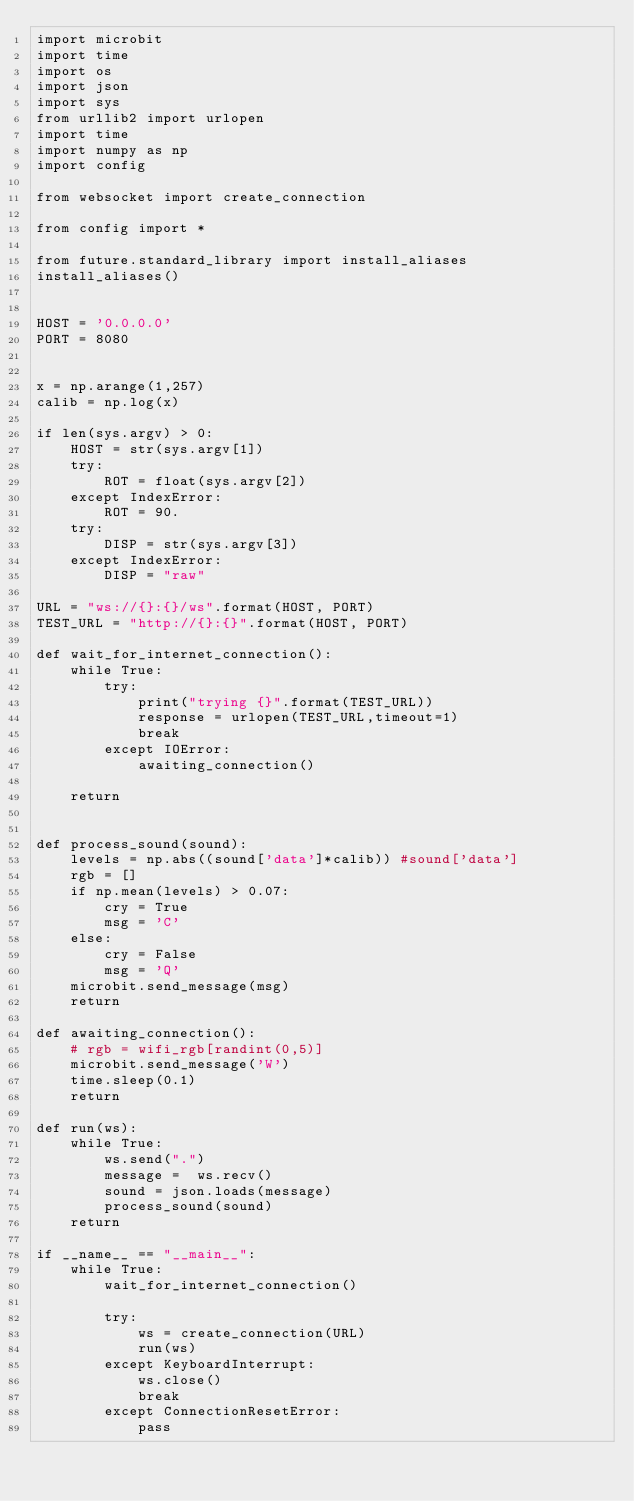Convert code to text. <code><loc_0><loc_0><loc_500><loc_500><_Python_>import microbit
import time
import os
import json
import sys
from urllib2 import urlopen
import time
import numpy as np
import config

from websocket import create_connection

from config import *

from future.standard_library import install_aliases
install_aliases()


HOST = '0.0.0.0'
PORT = 8080


x = np.arange(1,257)
calib = np.log(x)

if len(sys.argv) > 0:
    HOST = str(sys.argv[1])
    try:
        ROT = float(sys.argv[2])
    except IndexError:
        ROT = 90.
    try:
        DISP = str(sys.argv[3])
    except IndexError:
        DISP = "raw"

URL = "ws://{}:{}/ws".format(HOST, PORT)
TEST_URL = "http://{}:{}".format(HOST, PORT)

def wait_for_internet_connection():
    while True:
        try:
            print("trying {}".format(TEST_URL))
            response = urlopen(TEST_URL,timeout=1)
            break
        except IOError:
            awaiting_connection()

    return


def process_sound(sound):
    levels = np.abs((sound['data']*calib)) #sound['data']
    rgb = []
    if np.mean(levels) > 0.07:
        cry = True
        msg = 'C'
    else:
        cry = False
        msg = 'Q'
    microbit.send_message(msg)
    return

def awaiting_connection():
    # rgb = wifi_rgb[randint(0,5)]
    microbit.send_message('W')
    time.sleep(0.1)
    return

def run(ws):
    while True:
        ws.send(".")
        message =  ws.recv()
        sound = json.loads(message)
        process_sound(sound)
    return

if __name__ == "__main__":
    while True:
        wait_for_internet_connection()

        try:
            ws = create_connection(URL)
            run(ws)
        except KeyboardInterrupt:
            ws.close()
            break
        except ConnectionResetError:
            pass
</code> 